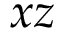<formula> <loc_0><loc_0><loc_500><loc_500>x z</formula> 